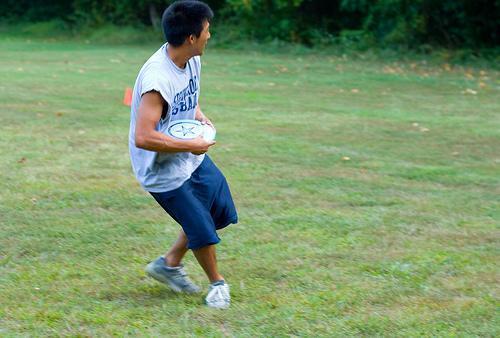How many people are there?
Give a very brief answer. 1. 